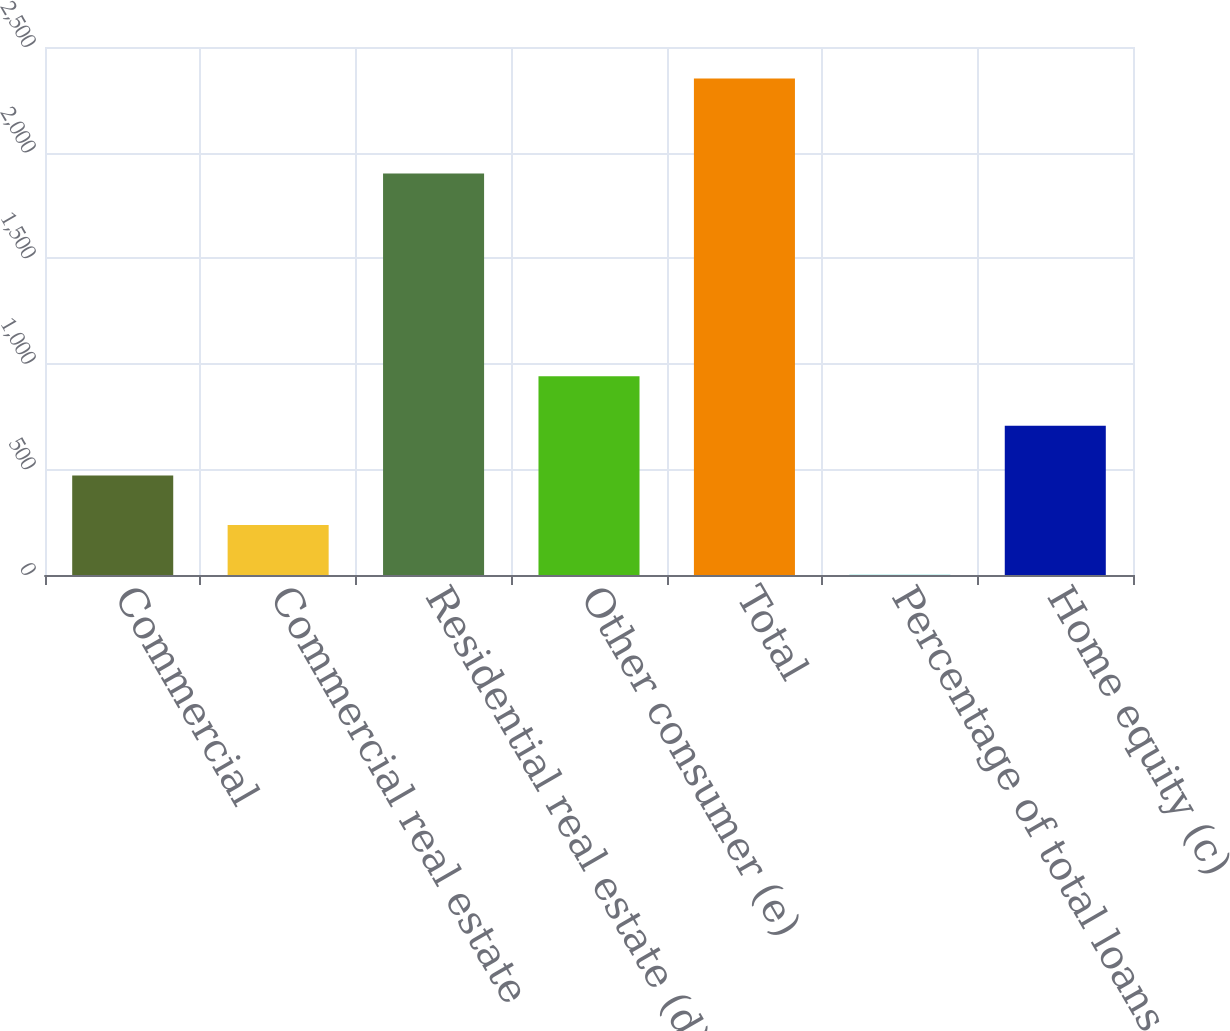<chart> <loc_0><loc_0><loc_500><loc_500><bar_chart><fcel>Commercial<fcel>Commercial real estate<fcel>Residential real estate (d)<fcel>Other consumer (e)<fcel>Total<fcel>Percentage of total loans<fcel>Home equity (c)<nl><fcel>471.2<fcel>236.23<fcel>1901<fcel>941.14<fcel>2351<fcel>1.26<fcel>706.17<nl></chart> 